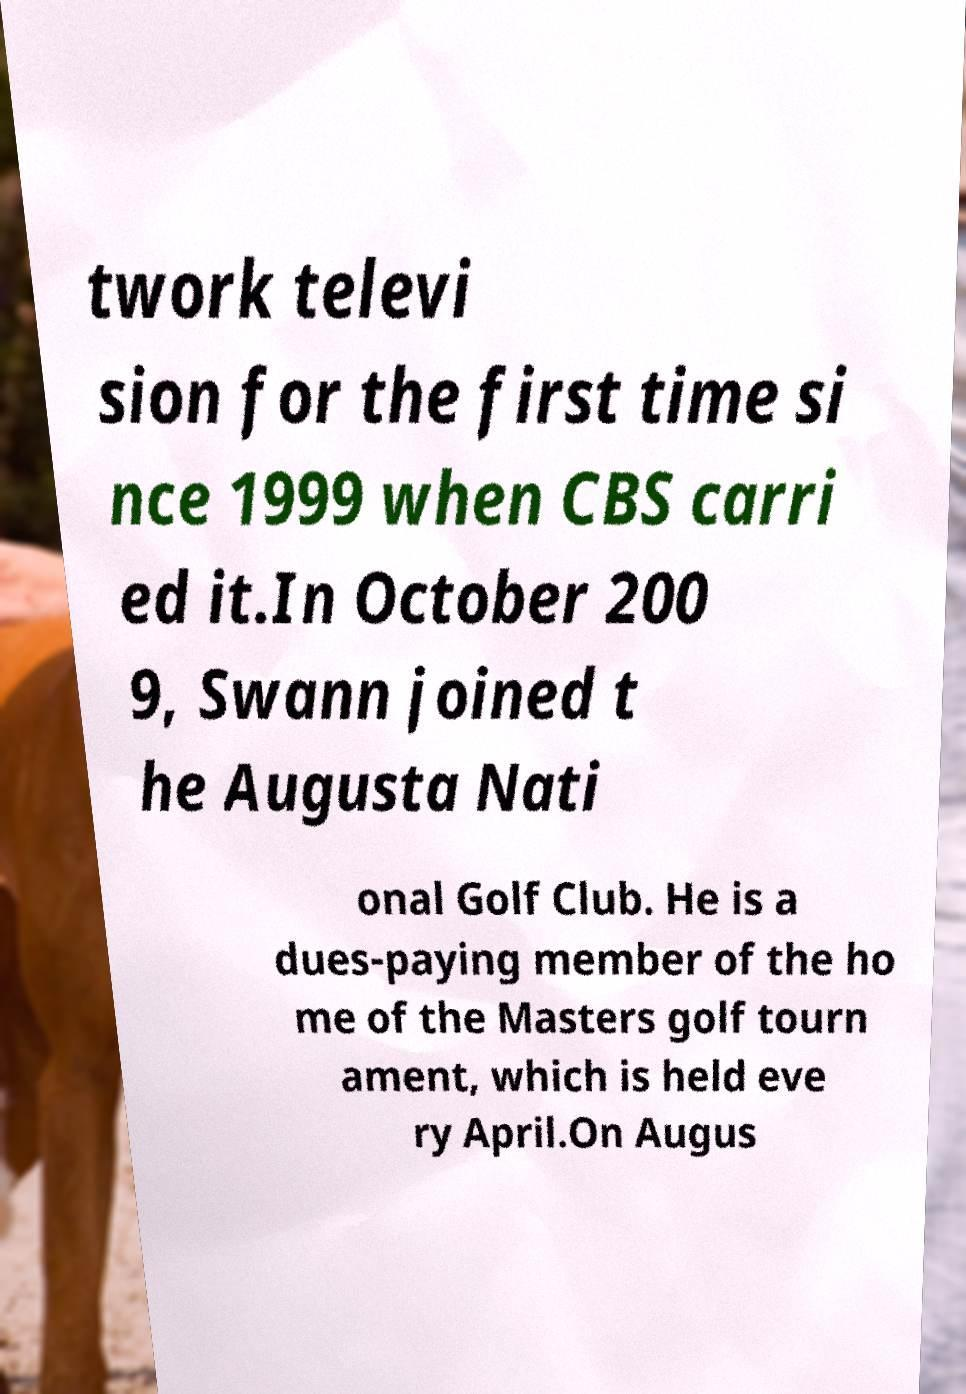Can you accurately transcribe the text from the provided image for me? twork televi sion for the first time si nce 1999 when CBS carri ed it.In October 200 9, Swann joined t he Augusta Nati onal Golf Club. He is a dues-paying member of the ho me of the Masters golf tourn ament, which is held eve ry April.On Augus 